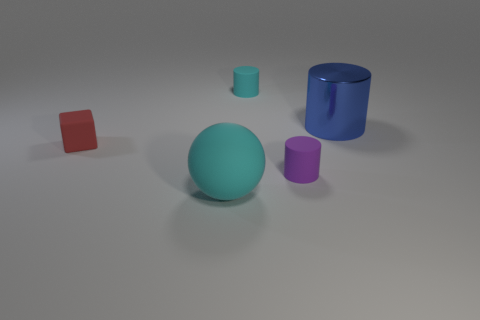Add 3 small cyan objects. How many objects exist? 8 Subtract all balls. How many objects are left? 4 Subtract all blue metal things. Subtract all big blue metal cylinders. How many objects are left? 3 Add 2 blue shiny cylinders. How many blue shiny cylinders are left? 3 Add 5 large brown metallic cylinders. How many large brown metallic cylinders exist? 5 Subtract 0 blue spheres. How many objects are left? 5 